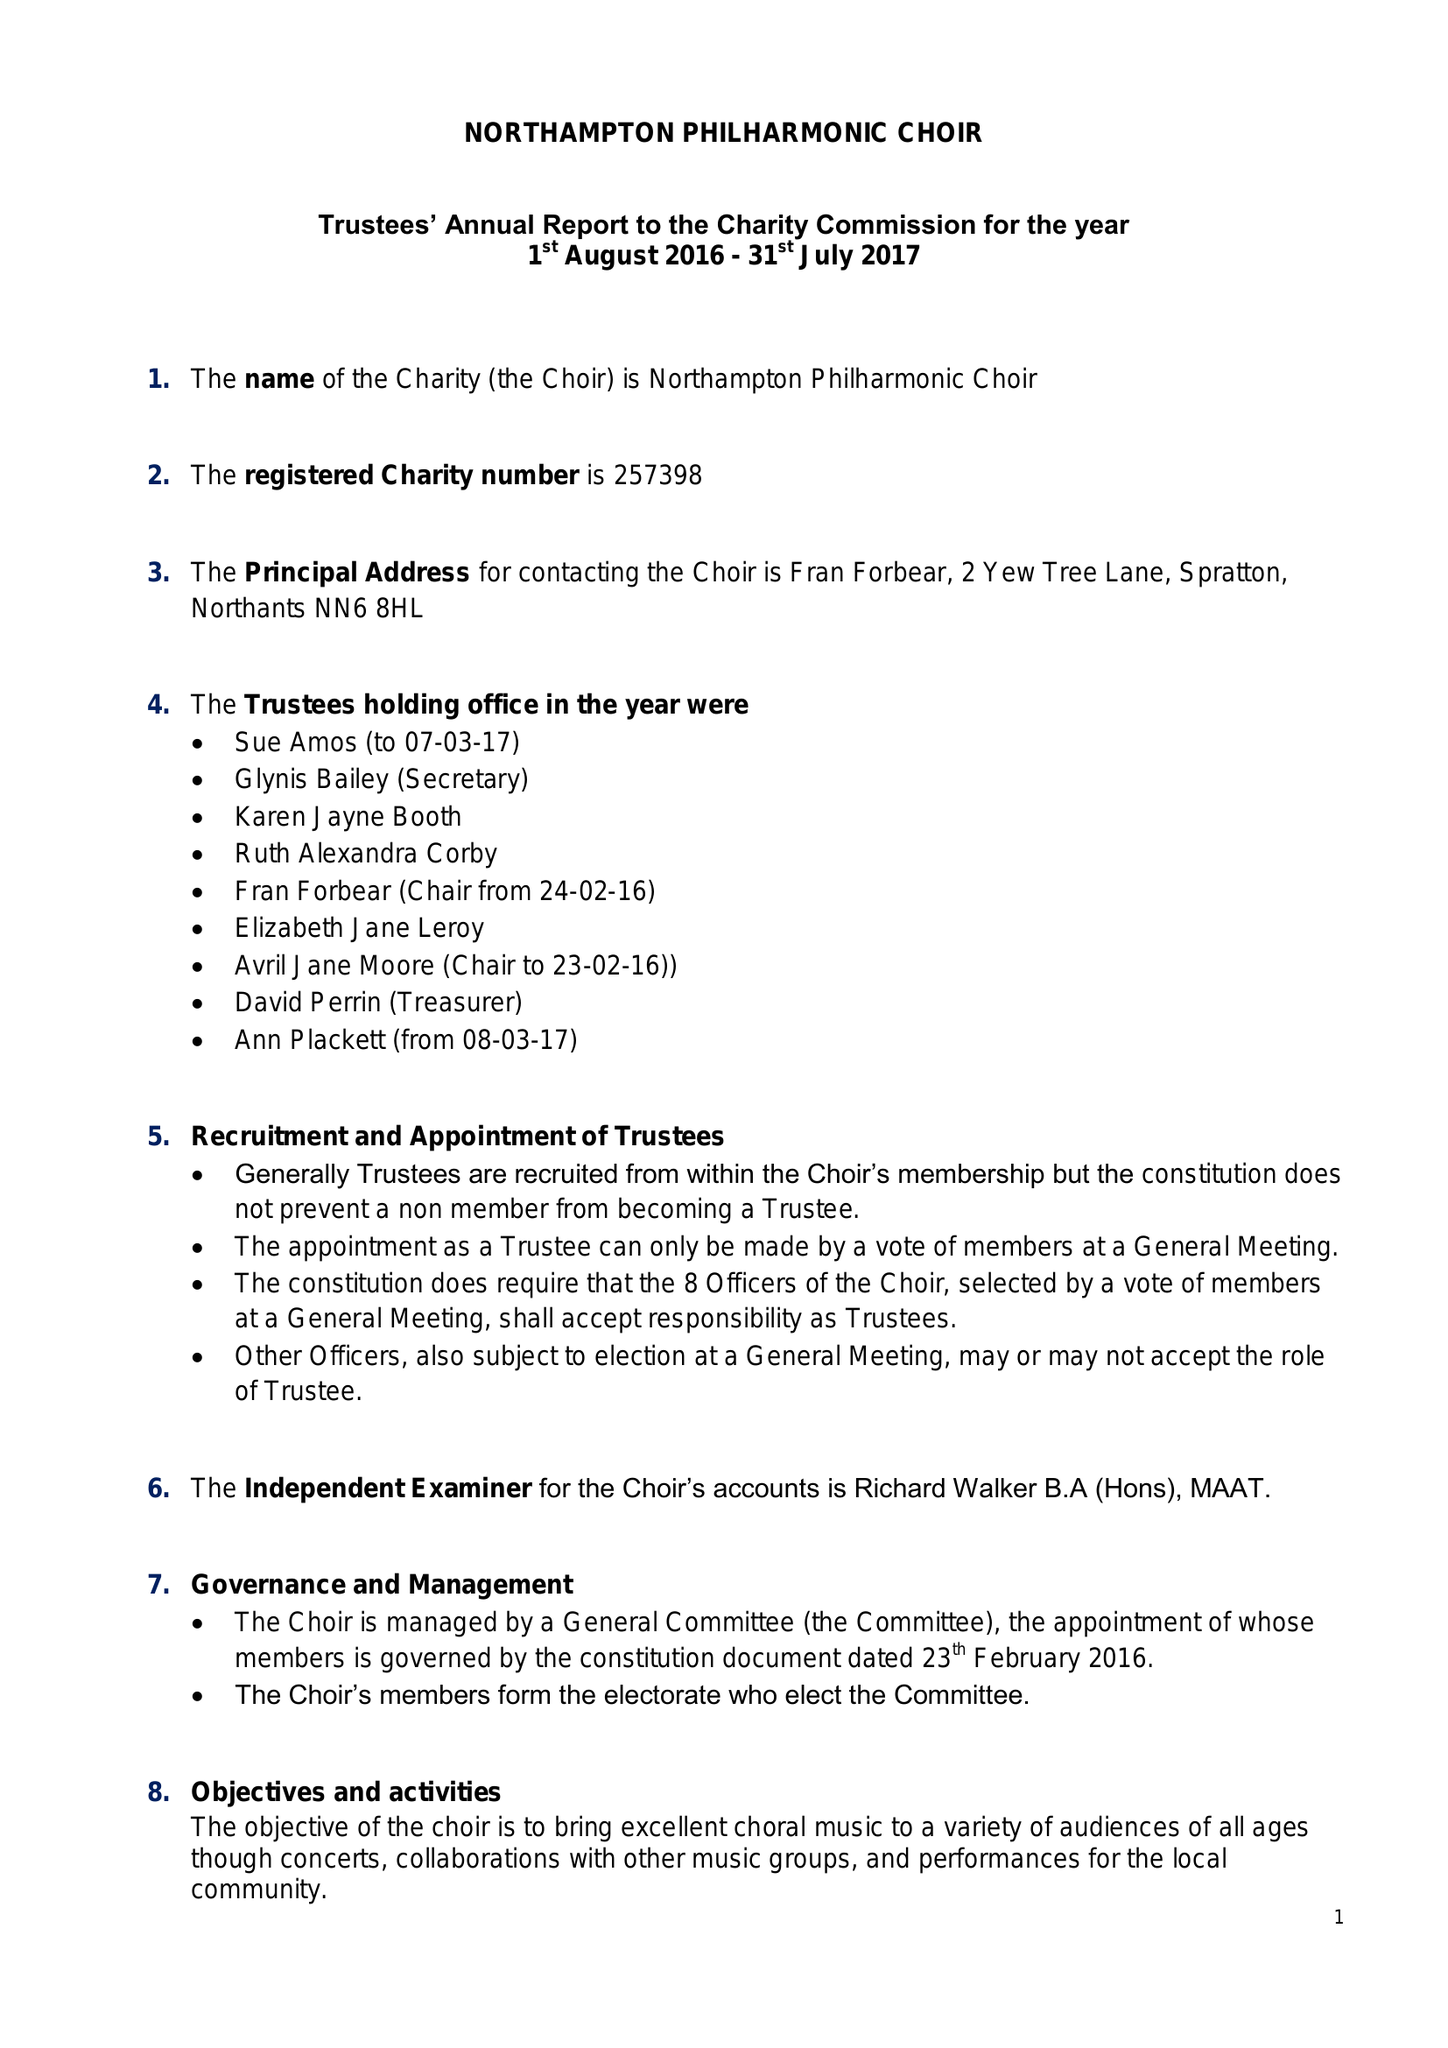What is the value for the address__postcode?
Answer the question using a single word or phrase. NN6 8HL 